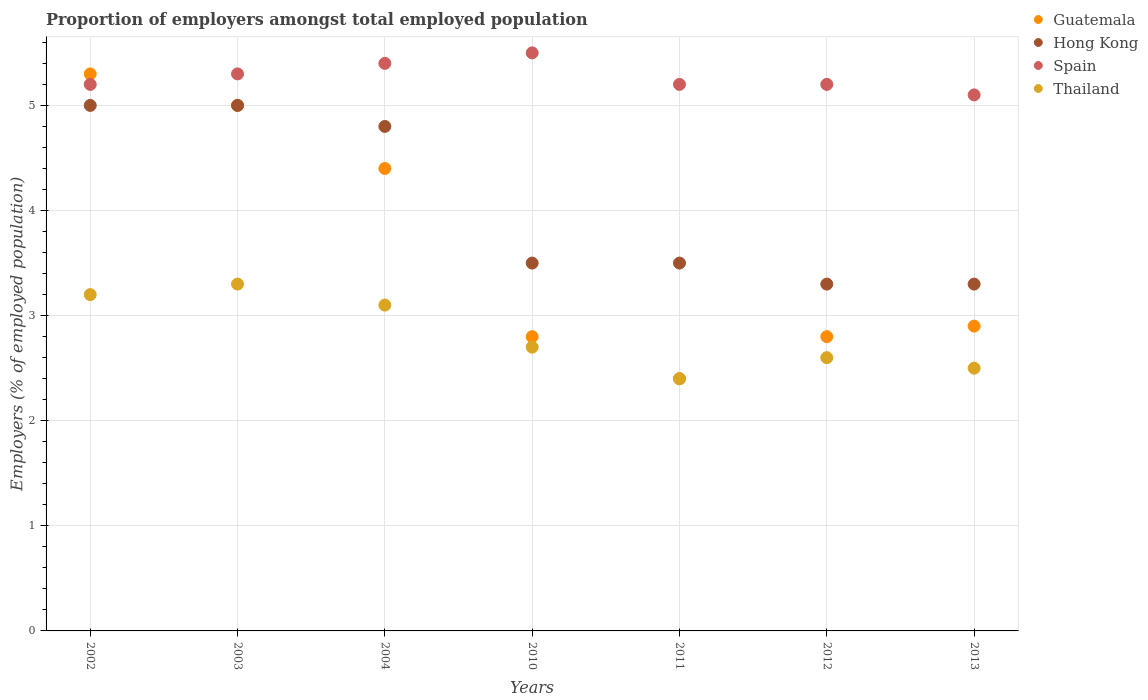Is the number of dotlines equal to the number of legend labels?
Offer a terse response. Yes. What is the proportion of employers in Hong Kong in 2013?
Offer a terse response. 3.3. Across all years, what is the maximum proportion of employers in Thailand?
Make the answer very short. 3.3. Across all years, what is the minimum proportion of employers in Guatemala?
Make the answer very short. 2.4. In which year was the proportion of employers in Thailand maximum?
Give a very brief answer. 2003. What is the total proportion of employers in Guatemala in the graph?
Make the answer very short. 25.6. What is the difference between the proportion of employers in Thailand in 2011 and that in 2012?
Your answer should be very brief. -0.2. What is the difference between the proportion of employers in Spain in 2002 and the proportion of employers in Guatemala in 2003?
Offer a terse response. 0.2. What is the average proportion of employers in Hong Kong per year?
Make the answer very short. 4.06. In the year 2012, what is the difference between the proportion of employers in Spain and proportion of employers in Guatemala?
Keep it short and to the point. 2.4. What is the ratio of the proportion of employers in Hong Kong in 2002 to that in 2003?
Make the answer very short. 1. Is the proportion of employers in Hong Kong in 2004 less than that in 2012?
Your answer should be compact. No. What is the difference between the highest and the second highest proportion of employers in Spain?
Keep it short and to the point. 0.1. What is the difference between the highest and the lowest proportion of employers in Guatemala?
Your answer should be compact. 2.9. Does the proportion of employers in Guatemala monotonically increase over the years?
Your response must be concise. No. How many dotlines are there?
Offer a terse response. 4. How many years are there in the graph?
Ensure brevity in your answer.  7. Are the values on the major ticks of Y-axis written in scientific E-notation?
Keep it short and to the point. No. Does the graph contain grids?
Your response must be concise. Yes. Where does the legend appear in the graph?
Provide a succinct answer. Top right. What is the title of the graph?
Provide a short and direct response. Proportion of employers amongst total employed population. Does "High income: nonOECD" appear as one of the legend labels in the graph?
Make the answer very short. No. What is the label or title of the X-axis?
Your response must be concise. Years. What is the label or title of the Y-axis?
Your answer should be compact. Employers (% of employed population). What is the Employers (% of employed population) in Guatemala in 2002?
Your response must be concise. 5.3. What is the Employers (% of employed population) of Hong Kong in 2002?
Keep it short and to the point. 5. What is the Employers (% of employed population) of Spain in 2002?
Provide a succinct answer. 5.2. What is the Employers (% of employed population) of Thailand in 2002?
Your response must be concise. 3.2. What is the Employers (% of employed population) in Guatemala in 2003?
Offer a terse response. 5. What is the Employers (% of employed population) of Hong Kong in 2003?
Provide a short and direct response. 5. What is the Employers (% of employed population) in Spain in 2003?
Offer a very short reply. 5.3. What is the Employers (% of employed population) in Thailand in 2003?
Give a very brief answer. 3.3. What is the Employers (% of employed population) in Guatemala in 2004?
Make the answer very short. 4.4. What is the Employers (% of employed population) in Hong Kong in 2004?
Your answer should be compact. 4.8. What is the Employers (% of employed population) in Spain in 2004?
Give a very brief answer. 5.4. What is the Employers (% of employed population) of Thailand in 2004?
Give a very brief answer. 3.1. What is the Employers (% of employed population) in Guatemala in 2010?
Your response must be concise. 2.8. What is the Employers (% of employed population) of Spain in 2010?
Ensure brevity in your answer.  5.5. What is the Employers (% of employed population) of Thailand in 2010?
Give a very brief answer. 2.7. What is the Employers (% of employed population) of Guatemala in 2011?
Your answer should be compact. 2.4. What is the Employers (% of employed population) in Hong Kong in 2011?
Keep it short and to the point. 3.5. What is the Employers (% of employed population) in Spain in 2011?
Your answer should be compact. 5.2. What is the Employers (% of employed population) in Thailand in 2011?
Keep it short and to the point. 2.4. What is the Employers (% of employed population) in Guatemala in 2012?
Your answer should be compact. 2.8. What is the Employers (% of employed population) of Hong Kong in 2012?
Provide a short and direct response. 3.3. What is the Employers (% of employed population) of Spain in 2012?
Provide a short and direct response. 5.2. What is the Employers (% of employed population) in Thailand in 2012?
Make the answer very short. 2.6. What is the Employers (% of employed population) of Guatemala in 2013?
Ensure brevity in your answer.  2.9. What is the Employers (% of employed population) in Hong Kong in 2013?
Provide a short and direct response. 3.3. What is the Employers (% of employed population) of Spain in 2013?
Ensure brevity in your answer.  5.1. Across all years, what is the maximum Employers (% of employed population) of Guatemala?
Offer a terse response. 5.3. Across all years, what is the maximum Employers (% of employed population) in Thailand?
Your answer should be compact. 3.3. Across all years, what is the minimum Employers (% of employed population) of Guatemala?
Offer a terse response. 2.4. Across all years, what is the minimum Employers (% of employed population) in Hong Kong?
Offer a very short reply. 3.3. Across all years, what is the minimum Employers (% of employed population) of Spain?
Your response must be concise. 5.1. Across all years, what is the minimum Employers (% of employed population) in Thailand?
Your answer should be very brief. 2.4. What is the total Employers (% of employed population) of Guatemala in the graph?
Provide a short and direct response. 25.6. What is the total Employers (% of employed population) in Hong Kong in the graph?
Provide a short and direct response. 28.4. What is the total Employers (% of employed population) in Spain in the graph?
Provide a succinct answer. 36.9. What is the total Employers (% of employed population) in Thailand in the graph?
Your response must be concise. 19.8. What is the difference between the Employers (% of employed population) of Guatemala in 2002 and that in 2003?
Your answer should be compact. 0.3. What is the difference between the Employers (% of employed population) in Guatemala in 2002 and that in 2010?
Your response must be concise. 2.5. What is the difference between the Employers (% of employed population) of Thailand in 2002 and that in 2010?
Give a very brief answer. 0.5. What is the difference between the Employers (% of employed population) of Spain in 2002 and that in 2011?
Offer a terse response. 0. What is the difference between the Employers (% of employed population) of Thailand in 2002 and that in 2011?
Ensure brevity in your answer.  0.8. What is the difference between the Employers (% of employed population) of Guatemala in 2002 and that in 2013?
Your answer should be compact. 2.4. What is the difference between the Employers (% of employed population) of Guatemala in 2003 and that in 2004?
Make the answer very short. 0.6. What is the difference between the Employers (% of employed population) of Hong Kong in 2003 and that in 2004?
Keep it short and to the point. 0.2. What is the difference between the Employers (% of employed population) of Thailand in 2003 and that in 2004?
Provide a succinct answer. 0.2. What is the difference between the Employers (% of employed population) in Guatemala in 2003 and that in 2010?
Offer a terse response. 2.2. What is the difference between the Employers (% of employed population) in Hong Kong in 2003 and that in 2010?
Ensure brevity in your answer.  1.5. What is the difference between the Employers (% of employed population) in Spain in 2003 and that in 2010?
Give a very brief answer. -0.2. What is the difference between the Employers (% of employed population) of Thailand in 2003 and that in 2010?
Make the answer very short. 0.6. What is the difference between the Employers (% of employed population) of Guatemala in 2003 and that in 2011?
Your answer should be very brief. 2.6. What is the difference between the Employers (% of employed population) in Spain in 2003 and that in 2011?
Keep it short and to the point. 0.1. What is the difference between the Employers (% of employed population) in Guatemala in 2003 and that in 2012?
Make the answer very short. 2.2. What is the difference between the Employers (% of employed population) in Hong Kong in 2003 and that in 2012?
Offer a terse response. 1.7. What is the difference between the Employers (% of employed population) of Spain in 2003 and that in 2012?
Keep it short and to the point. 0.1. What is the difference between the Employers (% of employed population) in Thailand in 2003 and that in 2012?
Your answer should be very brief. 0.7. What is the difference between the Employers (% of employed population) in Guatemala in 2003 and that in 2013?
Your answer should be very brief. 2.1. What is the difference between the Employers (% of employed population) of Spain in 2003 and that in 2013?
Make the answer very short. 0.2. What is the difference between the Employers (% of employed population) of Guatemala in 2004 and that in 2011?
Your answer should be very brief. 2. What is the difference between the Employers (% of employed population) of Hong Kong in 2004 and that in 2012?
Offer a terse response. 1.5. What is the difference between the Employers (% of employed population) in Guatemala in 2004 and that in 2013?
Offer a terse response. 1.5. What is the difference between the Employers (% of employed population) of Thailand in 2004 and that in 2013?
Provide a succinct answer. 0.6. What is the difference between the Employers (% of employed population) of Guatemala in 2010 and that in 2011?
Ensure brevity in your answer.  0.4. What is the difference between the Employers (% of employed population) in Hong Kong in 2010 and that in 2011?
Ensure brevity in your answer.  0. What is the difference between the Employers (% of employed population) in Thailand in 2010 and that in 2011?
Your answer should be compact. 0.3. What is the difference between the Employers (% of employed population) in Guatemala in 2010 and that in 2012?
Your answer should be compact. 0. What is the difference between the Employers (% of employed population) of Hong Kong in 2010 and that in 2012?
Provide a succinct answer. 0.2. What is the difference between the Employers (% of employed population) of Spain in 2010 and that in 2012?
Your answer should be compact. 0.3. What is the difference between the Employers (% of employed population) of Hong Kong in 2010 and that in 2013?
Offer a terse response. 0.2. What is the difference between the Employers (% of employed population) of Thailand in 2010 and that in 2013?
Your response must be concise. 0.2. What is the difference between the Employers (% of employed population) in Guatemala in 2011 and that in 2012?
Offer a terse response. -0.4. What is the difference between the Employers (% of employed population) in Thailand in 2011 and that in 2012?
Your response must be concise. -0.2. What is the difference between the Employers (% of employed population) in Guatemala in 2011 and that in 2013?
Offer a very short reply. -0.5. What is the difference between the Employers (% of employed population) of Spain in 2011 and that in 2013?
Offer a very short reply. 0.1. What is the difference between the Employers (% of employed population) in Thailand in 2011 and that in 2013?
Offer a terse response. -0.1. What is the difference between the Employers (% of employed population) in Guatemala in 2012 and that in 2013?
Your answer should be very brief. -0.1. What is the difference between the Employers (% of employed population) in Guatemala in 2002 and the Employers (% of employed population) in Spain in 2003?
Your answer should be compact. 0. What is the difference between the Employers (% of employed population) in Hong Kong in 2002 and the Employers (% of employed population) in Spain in 2003?
Provide a succinct answer. -0.3. What is the difference between the Employers (% of employed population) of Guatemala in 2002 and the Employers (% of employed population) of Hong Kong in 2004?
Offer a very short reply. 0.5. What is the difference between the Employers (% of employed population) in Guatemala in 2002 and the Employers (% of employed population) in Thailand in 2004?
Offer a terse response. 2.2. What is the difference between the Employers (% of employed population) of Hong Kong in 2002 and the Employers (% of employed population) of Thailand in 2004?
Give a very brief answer. 1.9. What is the difference between the Employers (% of employed population) of Spain in 2002 and the Employers (% of employed population) of Thailand in 2004?
Give a very brief answer. 2.1. What is the difference between the Employers (% of employed population) of Guatemala in 2002 and the Employers (% of employed population) of Hong Kong in 2010?
Offer a very short reply. 1.8. What is the difference between the Employers (% of employed population) of Guatemala in 2002 and the Employers (% of employed population) of Spain in 2010?
Make the answer very short. -0.2. What is the difference between the Employers (% of employed population) in Guatemala in 2002 and the Employers (% of employed population) in Thailand in 2010?
Ensure brevity in your answer.  2.6. What is the difference between the Employers (% of employed population) in Hong Kong in 2002 and the Employers (% of employed population) in Spain in 2010?
Your answer should be very brief. -0.5. What is the difference between the Employers (% of employed population) of Hong Kong in 2002 and the Employers (% of employed population) of Thailand in 2010?
Provide a short and direct response. 2.3. What is the difference between the Employers (% of employed population) of Spain in 2002 and the Employers (% of employed population) of Thailand in 2010?
Ensure brevity in your answer.  2.5. What is the difference between the Employers (% of employed population) in Guatemala in 2002 and the Employers (% of employed population) in Spain in 2011?
Provide a short and direct response. 0.1. What is the difference between the Employers (% of employed population) of Guatemala in 2002 and the Employers (% of employed population) of Thailand in 2011?
Your response must be concise. 2.9. What is the difference between the Employers (% of employed population) of Hong Kong in 2002 and the Employers (% of employed population) of Spain in 2011?
Offer a terse response. -0.2. What is the difference between the Employers (% of employed population) of Spain in 2002 and the Employers (% of employed population) of Thailand in 2011?
Provide a short and direct response. 2.8. What is the difference between the Employers (% of employed population) of Hong Kong in 2002 and the Employers (% of employed population) of Spain in 2012?
Your answer should be very brief. -0.2. What is the difference between the Employers (% of employed population) of Guatemala in 2002 and the Employers (% of employed population) of Spain in 2013?
Ensure brevity in your answer.  0.2. What is the difference between the Employers (% of employed population) in Guatemala in 2002 and the Employers (% of employed population) in Thailand in 2013?
Your response must be concise. 2.8. What is the difference between the Employers (% of employed population) in Hong Kong in 2002 and the Employers (% of employed population) in Thailand in 2013?
Your answer should be very brief. 2.5. What is the difference between the Employers (% of employed population) in Guatemala in 2003 and the Employers (% of employed population) in Hong Kong in 2004?
Keep it short and to the point. 0.2. What is the difference between the Employers (% of employed population) in Guatemala in 2003 and the Employers (% of employed population) in Thailand in 2004?
Make the answer very short. 1.9. What is the difference between the Employers (% of employed population) of Hong Kong in 2003 and the Employers (% of employed population) of Spain in 2010?
Offer a very short reply. -0.5. What is the difference between the Employers (% of employed population) of Hong Kong in 2003 and the Employers (% of employed population) of Thailand in 2010?
Your response must be concise. 2.3. What is the difference between the Employers (% of employed population) of Spain in 2003 and the Employers (% of employed population) of Thailand in 2010?
Offer a very short reply. 2.6. What is the difference between the Employers (% of employed population) of Hong Kong in 2003 and the Employers (% of employed population) of Spain in 2011?
Keep it short and to the point. -0.2. What is the difference between the Employers (% of employed population) in Hong Kong in 2003 and the Employers (% of employed population) in Thailand in 2011?
Ensure brevity in your answer.  2.6. What is the difference between the Employers (% of employed population) in Guatemala in 2003 and the Employers (% of employed population) in Thailand in 2013?
Ensure brevity in your answer.  2.5. What is the difference between the Employers (% of employed population) in Hong Kong in 2003 and the Employers (% of employed population) in Spain in 2013?
Your answer should be very brief. -0.1. What is the difference between the Employers (% of employed population) in Hong Kong in 2003 and the Employers (% of employed population) in Thailand in 2013?
Your answer should be compact. 2.5. What is the difference between the Employers (% of employed population) in Guatemala in 2004 and the Employers (% of employed population) in Hong Kong in 2010?
Offer a very short reply. 0.9. What is the difference between the Employers (% of employed population) in Guatemala in 2004 and the Employers (% of employed population) in Spain in 2010?
Provide a short and direct response. -1.1. What is the difference between the Employers (% of employed population) of Guatemala in 2004 and the Employers (% of employed population) of Thailand in 2010?
Provide a short and direct response. 1.7. What is the difference between the Employers (% of employed population) in Hong Kong in 2004 and the Employers (% of employed population) in Spain in 2010?
Your answer should be compact. -0.7. What is the difference between the Employers (% of employed population) of Guatemala in 2004 and the Employers (% of employed population) of Hong Kong in 2011?
Your answer should be compact. 0.9. What is the difference between the Employers (% of employed population) in Guatemala in 2004 and the Employers (% of employed population) in Thailand in 2011?
Keep it short and to the point. 2. What is the difference between the Employers (% of employed population) of Hong Kong in 2004 and the Employers (% of employed population) of Spain in 2011?
Provide a short and direct response. -0.4. What is the difference between the Employers (% of employed population) of Guatemala in 2004 and the Employers (% of employed population) of Spain in 2012?
Your answer should be very brief. -0.8. What is the difference between the Employers (% of employed population) of Hong Kong in 2004 and the Employers (% of employed population) of Thailand in 2012?
Ensure brevity in your answer.  2.2. What is the difference between the Employers (% of employed population) in Spain in 2004 and the Employers (% of employed population) in Thailand in 2012?
Your response must be concise. 2.8. What is the difference between the Employers (% of employed population) in Guatemala in 2004 and the Employers (% of employed population) in Hong Kong in 2013?
Provide a succinct answer. 1.1. What is the difference between the Employers (% of employed population) in Guatemala in 2004 and the Employers (% of employed population) in Spain in 2013?
Make the answer very short. -0.7. What is the difference between the Employers (% of employed population) in Spain in 2004 and the Employers (% of employed population) in Thailand in 2013?
Offer a very short reply. 2.9. What is the difference between the Employers (% of employed population) in Guatemala in 2010 and the Employers (% of employed population) in Hong Kong in 2011?
Provide a succinct answer. -0.7. What is the difference between the Employers (% of employed population) in Guatemala in 2010 and the Employers (% of employed population) in Spain in 2011?
Keep it short and to the point. -2.4. What is the difference between the Employers (% of employed population) of Spain in 2010 and the Employers (% of employed population) of Thailand in 2011?
Your response must be concise. 3.1. What is the difference between the Employers (% of employed population) in Guatemala in 2010 and the Employers (% of employed population) in Hong Kong in 2012?
Ensure brevity in your answer.  -0.5. What is the difference between the Employers (% of employed population) in Guatemala in 2010 and the Employers (% of employed population) in Spain in 2012?
Your response must be concise. -2.4. What is the difference between the Employers (% of employed population) of Hong Kong in 2010 and the Employers (% of employed population) of Spain in 2012?
Provide a short and direct response. -1.7. What is the difference between the Employers (% of employed population) of Hong Kong in 2010 and the Employers (% of employed population) of Thailand in 2012?
Make the answer very short. 0.9. What is the difference between the Employers (% of employed population) of Guatemala in 2010 and the Employers (% of employed population) of Hong Kong in 2013?
Give a very brief answer. -0.5. What is the difference between the Employers (% of employed population) in Guatemala in 2010 and the Employers (% of employed population) in Thailand in 2013?
Your answer should be very brief. 0.3. What is the difference between the Employers (% of employed population) in Hong Kong in 2010 and the Employers (% of employed population) in Spain in 2013?
Provide a succinct answer. -1.6. What is the difference between the Employers (% of employed population) of Hong Kong in 2010 and the Employers (% of employed population) of Thailand in 2013?
Give a very brief answer. 1. What is the difference between the Employers (% of employed population) of Spain in 2010 and the Employers (% of employed population) of Thailand in 2013?
Keep it short and to the point. 3. What is the difference between the Employers (% of employed population) of Guatemala in 2011 and the Employers (% of employed population) of Spain in 2012?
Ensure brevity in your answer.  -2.8. What is the difference between the Employers (% of employed population) of Guatemala in 2011 and the Employers (% of employed population) of Spain in 2013?
Ensure brevity in your answer.  -2.7. What is the difference between the Employers (% of employed population) in Hong Kong in 2011 and the Employers (% of employed population) in Spain in 2013?
Ensure brevity in your answer.  -1.6. What is the difference between the Employers (% of employed population) of Guatemala in 2012 and the Employers (% of employed population) of Hong Kong in 2013?
Your answer should be very brief. -0.5. What is the difference between the Employers (% of employed population) in Guatemala in 2012 and the Employers (% of employed population) in Spain in 2013?
Provide a succinct answer. -2.3. What is the difference between the Employers (% of employed population) of Hong Kong in 2012 and the Employers (% of employed population) of Spain in 2013?
Ensure brevity in your answer.  -1.8. What is the difference between the Employers (% of employed population) of Hong Kong in 2012 and the Employers (% of employed population) of Thailand in 2013?
Provide a succinct answer. 0.8. What is the difference between the Employers (% of employed population) in Spain in 2012 and the Employers (% of employed population) in Thailand in 2013?
Keep it short and to the point. 2.7. What is the average Employers (% of employed population) in Guatemala per year?
Your response must be concise. 3.66. What is the average Employers (% of employed population) in Hong Kong per year?
Your answer should be very brief. 4.06. What is the average Employers (% of employed population) of Spain per year?
Give a very brief answer. 5.27. What is the average Employers (% of employed population) of Thailand per year?
Your answer should be very brief. 2.83. In the year 2002, what is the difference between the Employers (% of employed population) of Guatemala and Employers (% of employed population) of Thailand?
Your response must be concise. 2.1. In the year 2002, what is the difference between the Employers (% of employed population) in Spain and Employers (% of employed population) in Thailand?
Offer a terse response. 2. In the year 2003, what is the difference between the Employers (% of employed population) in Guatemala and Employers (% of employed population) in Hong Kong?
Give a very brief answer. 0. In the year 2003, what is the difference between the Employers (% of employed population) in Guatemala and Employers (% of employed population) in Thailand?
Keep it short and to the point. 1.7. In the year 2003, what is the difference between the Employers (% of employed population) in Hong Kong and Employers (% of employed population) in Thailand?
Provide a succinct answer. 1.7. In the year 2003, what is the difference between the Employers (% of employed population) of Spain and Employers (% of employed population) of Thailand?
Provide a succinct answer. 2. In the year 2004, what is the difference between the Employers (% of employed population) in Guatemala and Employers (% of employed population) in Spain?
Give a very brief answer. -1. In the year 2004, what is the difference between the Employers (% of employed population) of Guatemala and Employers (% of employed population) of Thailand?
Offer a terse response. 1.3. In the year 2004, what is the difference between the Employers (% of employed population) of Hong Kong and Employers (% of employed population) of Spain?
Provide a succinct answer. -0.6. In the year 2004, what is the difference between the Employers (% of employed population) in Hong Kong and Employers (% of employed population) in Thailand?
Provide a succinct answer. 1.7. In the year 2010, what is the difference between the Employers (% of employed population) in Hong Kong and Employers (% of employed population) in Spain?
Make the answer very short. -2. In the year 2010, what is the difference between the Employers (% of employed population) in Hong Kong and Employers (% of employed population) in Thailand?
Give a very brief answer. 0.8. In the year 2011, what is the difference between the Employers (% of employed population) of Guatemala and Employers (% of employed population) of Thailand?
Make the answer very short. 0. In the year 2011, what is the difference between the Employers (% of employed population) in Hong Kong and Employers (% of employed population) in Spain?
Make the answer very short. -1.7. In the year 2011, what is the difference between the Employers (% of employed population) in Hong Kong and Employers (% of employed population) in Thailand?
Offer a terse response. 1.1. In the year 2011, what is the difference between the Employers (% of employed population) of Spain and Employers (% of employed population) of Thailand?
Provide a short and direct response. 2.8. In the year 2012, what is the difference between the Employers (% of employed population) in Guatemala and Employers (% of employed population) in Thailand?
Make the answer very short. 0.2. In the year 2012, what is the difference between the Employers (% of employed population) of Hong Kong and Employers (% of employed population) of Spain?
Provide a short and direct response. -1.9. In the year 2012, what is the difference between the Employers (% of employed population) of Hong Kong and Employers (% of employed population) of Thailand?
Ensure brevity in your answer.  0.7. In the year 2012, what is the difference between the Employers (% of employed population) of Spain and Employers (% of employed population) of Thailand?
Keep it short and to the point. 2.6. In the year 2013, what is the difference between the Employers (% of employed population) in Guatemala and Employers (% of employed population) in Hong Kong?
Your response must be concise. -0.4. In the year 2013, what is the difference between the Employers (% of employed population) of Guatemala and Employers (% of employed population) of Spain?
Make the answer very short. -2.2. In the year 2013, what is the difference between the Employers (% of employed population) of Guatemala and Employers (% of employed population) of Thailand?
Ensure brevity in your answer.  0.4. In the year 2013, what is the difference between the Employers (% of employed population) of Hong Kong and Employers (% of employed population) of Spain?
Offer a very short reply. -1.8. In the year 2013, what is the difference between the Employers (% of employed population) in Spain and Employers (% of employed population) in Thailand?
Make the answer very short. 2.6. What is the ratio of the Employers (% of employed population) of Guatemala in 2002 to that in 2003?
Provide a short and direct response. 1.06. What is the ratio of the Employers (% of employed population) of Hong Kong in 2002 to that in 2003?
Offer a terse response. 1. What is the ratio of the Employers (% of employed population) of Spain in 2002 to that in 2003?
Offer a terse response. 0.98. What is the ratio of the Employers (% of employed population) of Thailand in 2002 to that in 2003?
Give a very brief answer. 0.97. What is the ratio of the Employers (% of employed population) of Guatemala in 2002 to that in 2004?
Your answer should be compact. 1.2. What is the ratio of the Employers (% of employed population) of Hong Kong in 2002 to that in 2004?
Provide a short and direct response. 1.04. What is the ratio of the Employers (% of employed population) in Spain in 2002 to that in 2004?
Your answer should be compact. 0.96. What is the ratio of the Employers (% of employed population) of Thailand in 2002 to that in 2004?
Keep it short and to the point. 1.03. What is the ratio of the Employers (% of employed population) of Guatemala in 2002 to that in 2010?
Your answer should be compact. 1.89. What is the ratio of the Employers (% of employed population) of Hong Kong in 2002 to that in 2010?
Keep it short and to the point. 1.43. What is the ratio of the Employers (% of employed population) of Spain in 2002 to that in 2010?
Provide a short and direct response. 0.95. What is the ratio of the Employers (% of employed population) of Thailand in 2002 to that in 2010?
Ensure brevity in your answer.  1.19. What is the ratio of the Employers (% of employed population) of Guatemala in 2002 to that in 2011?
Keep it short and to the point. 2.21. What is the ratio of the Employers (% of employed population) in Hong Kong in 2002 to that in 2011?
Offer a very short reply. 1.43. What is the ratio of the Employers (% of employed population) of Spain in 2002 to that in 2011?
Offer a terse response. 1. What is the ratio of the Employers (% of employed population) of Guatemala in 2002 to that in 2012?
Keep it short and to the point. 1.89. What is the ratio of the Employers (% of employed population) of Hong Kong in 2002 to that in 2012?
Provide a short and direct response. 1.52. What is the ratio of the Employers (% of employed population) of Spain in 2002 to that in 2012?
Ensure brevity in your answer.  1. What is the ratio of the Employers (% of employed population) of Thailand in 2002 to that in 2012?
Provide a short and direct response. 1.23. What is the ratio of the Employers (% of employed population) of Guatemala in 2002 to that in 2013?
Provide a short and direct response. 1.83. What is the ratio of the Employers (% of employed population) in Hong Kong in 2002 to that in 2013?
Offer a very short reply. 1.52. What is the ratio of the Employers (% of employed population) in Spain in 2002 to that in 2013?
Provide a succinct answer. 1.02. What is the ratio of the Employers (% of employed population) in Thailand in 2002 to that in 2013?
Your response must be concise. 1.28. What is the ratio of the Employers (% of employed population) of Guatemala in 2003 to that in 2004?
Give a very brief answer. 1.14. What is the ratio of the Employers (% of employed population) in Hong Kong in 2003 to that in 2004?
Your answer should be compact. 1.04. What is the ratio of the Employers (% of employed population) in Spain in 2003 to that in 2004?
Provide a short and direct response. 0.98. What is the ratio of the Employers (% of employed population) of Thailand in 2003 to that in 2004?
Keep it short and to the point. 1.06. What is the ratio of the Employers (% of employed population) in Guatemala in 2003 to that in 2010?
Offer a very short reply. 1.79. What is the ratio of the Employers (% of employed population) in Hong Kong in 2003 to that in 2010?
Keep it short and to the point. 1.43. What is the ratio of the Employers (% of employed population) of Spain in 2003 to that in 2010?
Ensure brevity in your answer.  0.96. What is the ratio of the Employers (% of employed population) in Thailand in 2003 to that in 2010?
Keep it short and to the point. 1.22. What is the ratio of the Employers (% of employed population) of Guatemala in 2003 to that in 2011?
Keep it short and to the point. 2.08. What is the ratio of the Employers (% of employed population) of Hong Kong in 2003 to that in 2011?
Your response must be concise. 1.43. What is the ratio of the Employers (% of employed population) of Spain in 2003 to that in 2011?
Ensure brevity in your answer.  1.02. What is the ratio of the Employers (% of employed population) of Thailand in 2003 to that in 2011?
Your response must be concise. 1.38. What is the ratio of the Employers (% of employed population) of Guatemala in 2003 to that in 2012?
Keep it short and to the point. 1.79. What is the ratio of the Employers (% of employed population) in Hong Kong in 2003 to that in 2012?
Keep it short and to the point. 1.52. What is the ratio of the Employers (% of employed population) in Spain in 2003 to that in 2012?
Provide a succinct answer. 1.02. What is the ratio of the Employers (% of employed population) of Thailand in 2003 to that in 2012?
Your response must be concise. 1.27. What is the ratio of the Employers (% of employed population) of Guatemala in 2003 to that in 2013?
Your response must be concise. 1.72. What is the ratio of the Employers (% of employed population) of Hong Kong in 2003 to that in 2013?
Ensure brevity in your answer.  1.52. What is the ratio of the Employers (% of employed population) of Spain in 2003 to that in 2013?
Your answer should be compact. 1.04. What is the ratio of the Employers (% of employed population) in Thailand in 2003 to that in 2013?
Ensure brevity in your answer.  1.32. What is the ratio of the Employers (% of employed population) of Guatemala in 2004 to that in 2010?
Keep it short and to the point. 1.57. What is the ratio of the Employers (% of employed population) of Hong Kong in 2004 to that in 2010?
Provide a short and direct response. 1.37. What is the ratio of the Employers (% of employed population) in Spain in 2004 to that in 2010?
Give a very brief answer. 0.98. What is the ratio of the Employers (% of employed population) of Thailand in 2004 to that in 2010?
Ensure brevity in your answer.  1.15. What is the ratio of the Employers (% of employed population) of Guatemala in 2004 to that in 2011?
Give a very brief answer. 1.83. What is the ratio of the Employers (% of employed population) of Hong Kong in 2004 to that in 2011?
Ensure brevity in your answer.  1.37. What is the ratio of the Employers (% of employed population) in Thailand in 2004 to that in 2011?
Your response must be concise. 1.29. What is the ratio of the Employers (% of employed population) of Guatemala in 2004 to that in 2012?
Your answer should be compact. 1.57. What is the ratio of the Employers (% of employed population) in Hong Kong in 2004 to that in 2012?
Give a very brief answer. 1.45. What is the ratio of the Employers (% of employed population) of Spain in 2004 to that in 2012?
Offer a very short reply. 1.04. What is the ratio of the Employers (% of employed population) of Thailand in 2004 to that in 2012?
Make the answer very short. 1.19. What is the ratio of the Employers (% of employed population) in Guatemala in 2004 to that in 2013?
Keep it short and to the point. 1.52. What is the ratio of the Employers (% of employed population) in Hong Kong in 2004 to that in 2013?
Give a very brief answer. 1.45. What is the ratio of the Employers (% of employed population) in Spain in 2004 to that in 2013?
Your answer should be very brief. 1.06. What is the ratio of the Employers (% of employed population) in Thailand in 2004 to that in 2013?
Offer a very short reply. 1.24. What is the ratio of the Employers (% of employed population) in Spain in 2010 to that in 2011?
Provide a short and direct response. 1.06. What is the ratio of the Employers (% of employed population) in Thailand in 2010 to that in 2011?
Your answer should be very brief. 1.12. What is the ratio of the Employers (% of employed population) in Hong Kong in 2010 to that in 2012?
Your answer should be compact. 1.06. What is the ratio of the Employers (% of employed population) in Spain in 2010 to that in 2012?
Give a very brief answer. 1.06. What is the ratio of the Employers (% of employed population) in Thailand in 2010 to that in 2012?
Provide a short and direct response. 1.04. What is the ratio of the Employers (% of employed population) of Guatemala in 2010 to that in 2013?
Make the answer very short. 0.97. What is the ratio of the Employers (% of employed population) of Hong Kong in 2010 to that in 2013?
Offer a very short reply. 1.06. What is the ratio of the Employers (% of employed population) of Spain in 2010 to that in 2013?
Make the answer very short. 1.08. What is the ratio of the Employers (% of employed population) of Guatemala in 2011 to that in 2012?
Give a very brief answer. 0.86. What is the ratio of the Employers (% of employed population) of Hong Kong in 2011 to that in 2012?
Offer a very short reply. 1.06. What is the ratio of the Employers (% of employed population) of Guatemala in 2011 to that in 2013?
Provide a succinct answer. 0.83. What is the ratio of the Employers (% of employed population) of Hong Kong in 2011 to that in 2013?
Give a very brief answer. 1.06. What is the ratio of the Employers (% of employed population) in Spain in 2011 to that in 2013?
Your answer should be compact. 1.02. What is the ratio of the Employers (% of employed population) in Guatemala in 2012 to that in 2013?
Your response must be concise. 0.97. What is the ratio of the Employers (% of employed population) of Spain in 2012 to that in 2013?
Ensure brevity in your answer.  1.02. What is the difference between the highest and the second highest Employers (% of employed population) of Guatemala?
Provide a short and direct response. 0.3. What is the difference between the highest and the second highest Employers (% of employed population) in Spain?
Your answer should be compact. 0.1. What is the difference between the highest and the lowest Employers (% of employed population) of Guatemala?
Ensure brevity in your answer.  2.9. What is the difference between the highest and the lowest Employers (% of employed population) of Spain?
Make the answer very short. 0.4. What is the difference between the highest and the lowest Employers (% of employed population) in Thailand?
Make the answer very short. 0.9. 